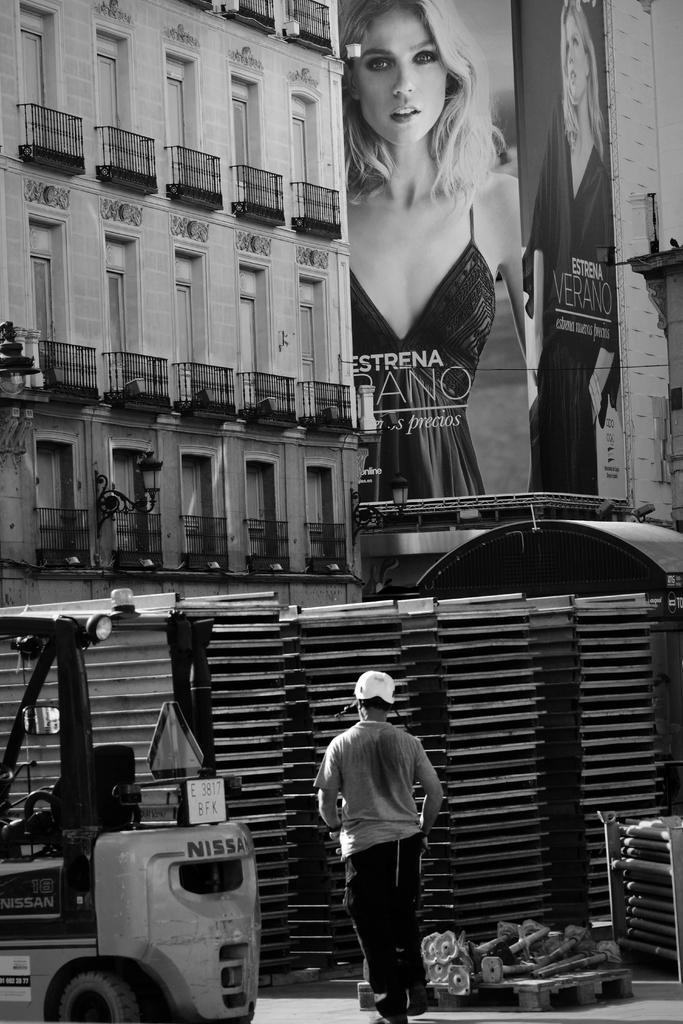Please provide a concise description of this image. This is a black and white image. I can see a person standing. At the bottom left side of the image, It looks like a vehicle and few objects. I can see a building with the windows and iron grilles. On the right side of the image, this is a hoarding with the pictures of the women and letters on it. 